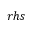<formula> <loc_0><loc_0><loc_500><loc_500>r h s</formula> 